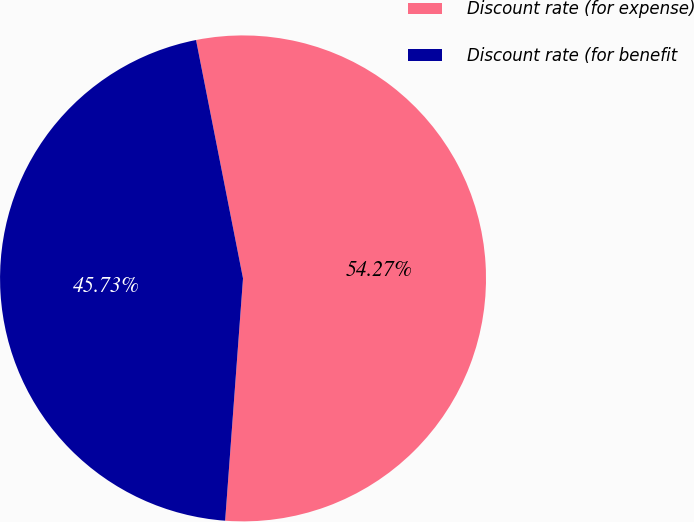<chart> <loc_0><loc_0><loc_500><loc_500><pie_chart><fcel>Discount rate (for expense)<fcel>Discount rate (for benefit<nl><fcel>54.27%<fcel>45.73%<nl></chart> 